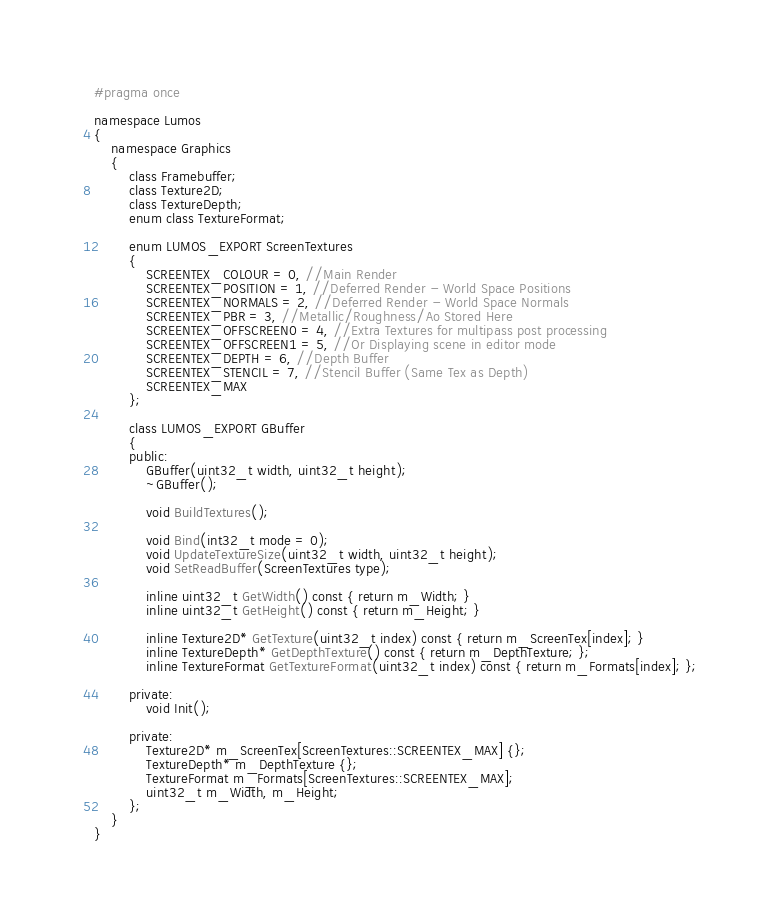<code> <loc_0><loc_0><loc_500><loc_500><_C_>#pragma once

namespace Lumos
{
    namespace Graphics
    {
        class Framebuffer;
        class Texture2D;
        class TextureDepth;
        enum class TextureFormat;

        enum LUMOS_EXPORT ScreenTextures
        {
            SCREENTEX_COLOUR = 0, //Main Render
            SCREENTEX_POSITION = 1, //Deferred Render - World Space Positions
            SCREENTEX_NORMALS = 2, //Deferred Render - World Space Normals
            SCREENTEX_PBR = 3, //Metallic/Roughness/Ao Stored Here
            SCREENTEX_OFFSCREEN0 = 4, //Extra Textures for multipass post processing
            SCREENTEX_OFFSCREEN1 = 5, //Or Displaying scene in editor mode
            SCREENTEX_DEPTH = 6, //Depth Buffer
            SCREENTEX_STENCIL = 7, //Stencil Buffer (Same Tex as Depth)
            SCREENTEX_MAX
        };

        class LUMOS_EXPORT GBuffer
        {
        public:
            GBuffer(uint32_t width, uint32_t height);
            ~GBuffer();

            void BuildTextures();

            void Bind(int32_t mode = 0);
            void UpdateTextureSize(uint32_t width, uint32_t height);
            void SetReadBuffer(ScreenTextures type);

            inline uint32_t GetWidth() const { return m_Width; }
            inline uint32_t GetHeight() const { return m_Height; }

            inline Texture2D* GetTexture(uint32_t index) const { return m_ScreenTex[index]; }
            inline TextureDepth* GetDepthTexture() const { return m_DepthTexture; };
            inline TextureFormat GetTextureFormat(uint32_t index) const { return m_Formats[index]; };

        private:
            void Init();

        private:
            Texture2D* m_ScreenTex[ScreenTextures::SCREENTEX_MAX] {};
            TextureDepth* m_DepthTexture {};
            TextureFormat m_Formats[ScreenTextures::SCREENTEX_MAX];
            uint32_t m_Width, m_Height;
        };
    }
}
</code> 